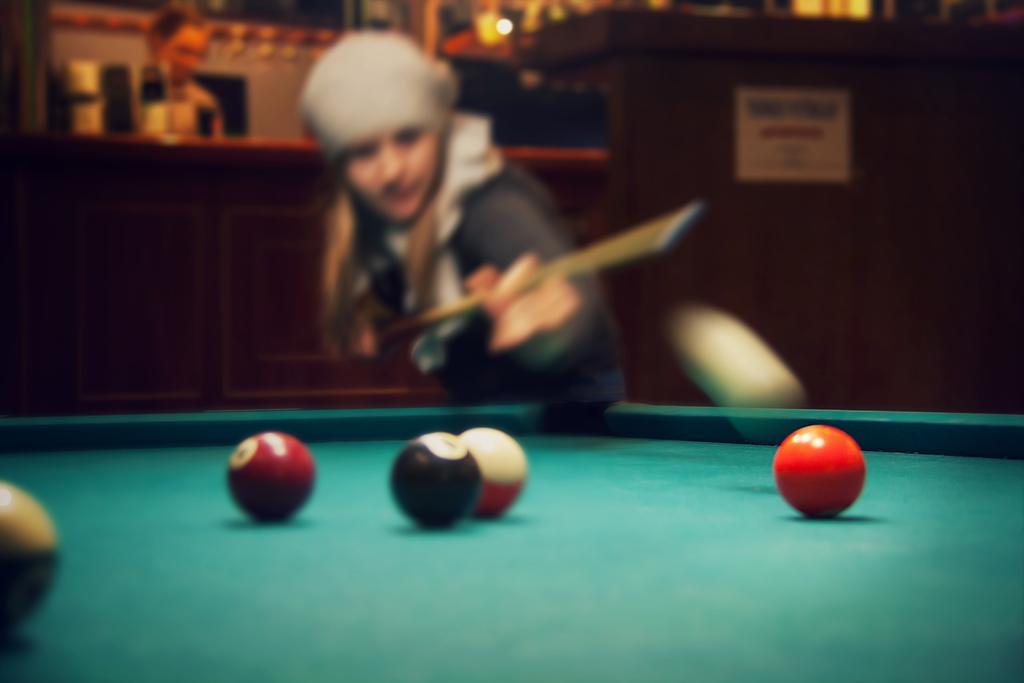Could you give a brief overview of what you see in this image? Here we can see a woman playing the snookers, and she is holding the stick in her hands, and here is the board, and here is the balls,and at back a person is standing. 